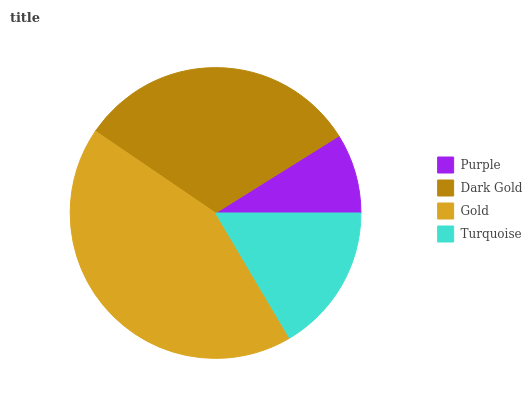Is Purple the minimum?
Answer yes or no. Yes. Is Gold the maximum?
Answer yes or no. Yes. Is Dark Gold the minimum?
Answer yes or no. No. Is Dark Gold the maximum?
Answer yes or no. No. Is Dark Gold greater than Purple?
Answer yes or no. Yes. Is Purple less than Dark Gold?
Answer yes or no. Yes. Is Purple greater than Dark Gold?
Answer yes or no. No. Is Dark Gold less than Purple?
Answer yes or no. No. Is Dark Gold the high median?
Answer yes or no. Yes. Is Turquoise the low median?
Answer yes or no. Yes. Is Purple the high median?
Answer yes or no. No. Is Gold the low median?
Answer yes or no. No. 